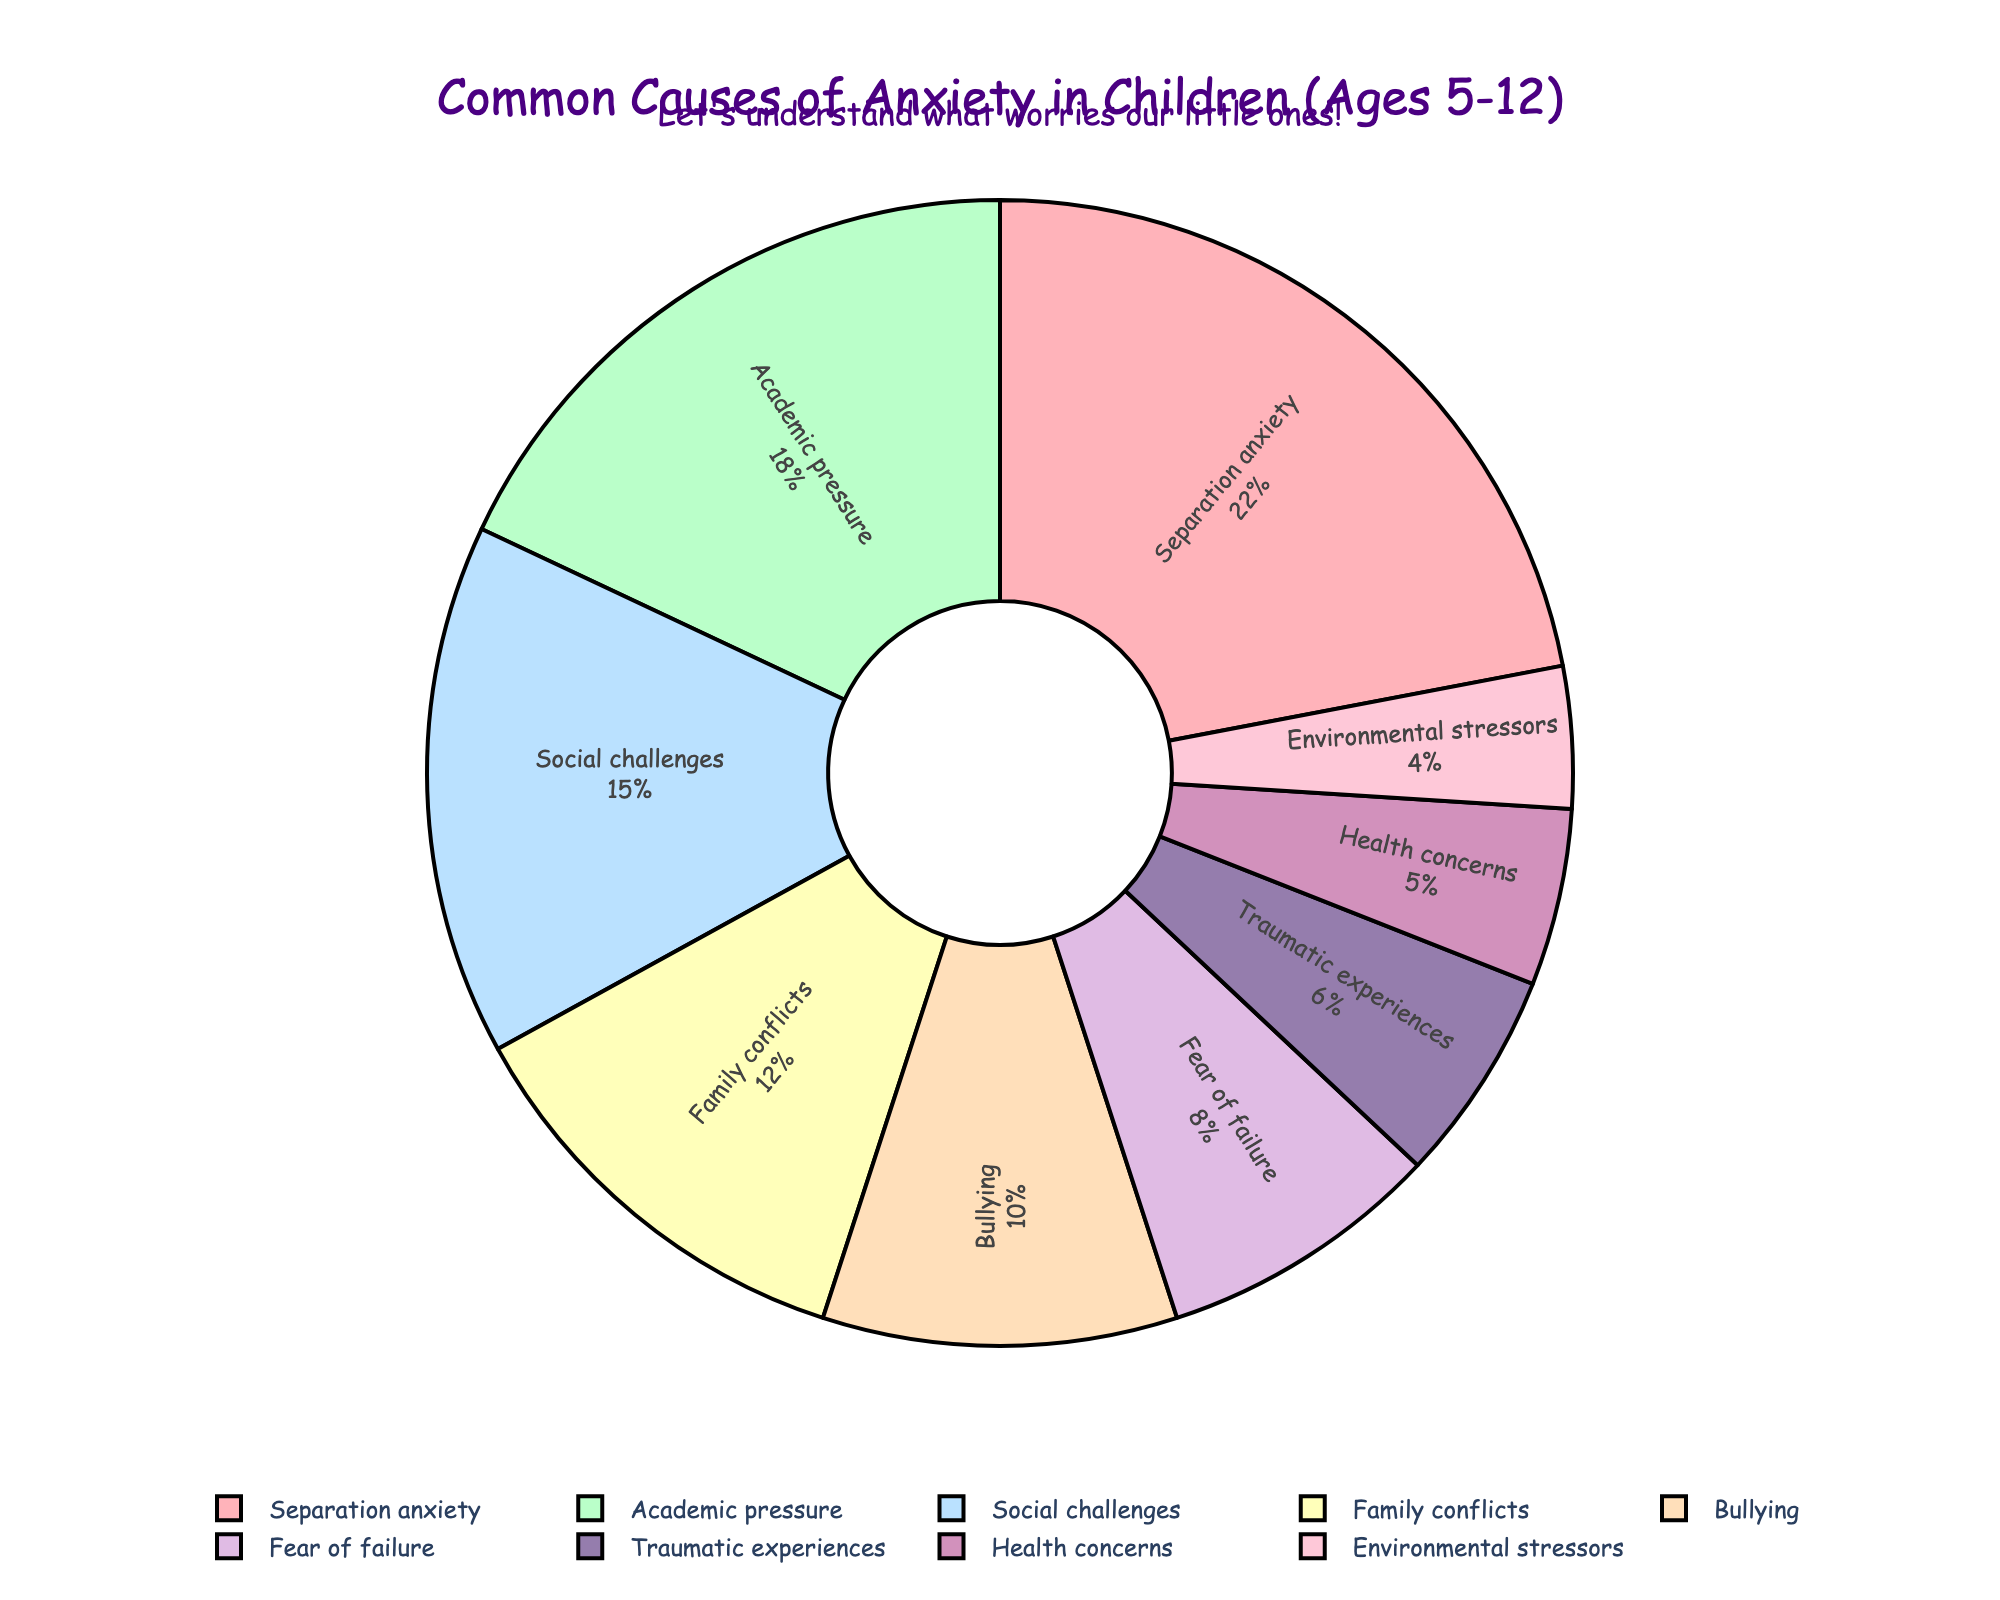Which cause has the highest percentage of anxiety in children aged 5-12? By observing the pie chart, the section representing "Separation anxiety" is the largest, which implies it has the highest percentage.
Answer: Separation anxiety Which causes make up more than 15% each? By looking at the pie chart, "Separation anxiety," "Academic pressure," and "Social challenges" have larger sections, each representing more than 15%.
Answer: Separation anxiety, Academic pressure, Social challenges How does the percentage of anxiety caused by "Family conflicts" compare to "Bullying"? Observing the pie chart, the section representing "Family conflicts" is larger than that of "Bullying."
Answer: Family conflicts is larger Which causes of anxiety are represented by the smallest sections in the pie chart? The smaller sections on the pie chart represent "Health concerns" and "Environmental stressors."
Answer: Health concerns, Environmental stressors What is the combined percentage of anxiety caused by "Traumatic experiences" and "Health concerns"? The pie chart shows "Traumatic experiences" at 6% and "Health concerns" at 5%. Adding these percentages together, the combined percentage is 6% + 5% = 11%.
Answer: 11% How much greater is the percentage for "Academic pressure" compared to "Fear of failure"? Comparing the pie chart percentages, "Academic pressure" is 18% and "Fear of failure" is 8%. The difference is 18% - 8% = 10%.
Answer: 10% Which causes of anxiety have a percentage within 2% of each other? By closely examining the pie chart, "Fear of failure" at 8% and "Traumatic experiences" at 6% are close, with only a 2% difference.
Answer: Fear of failure and Traumatic experiences What's the difference between the total percentage of "Separation anxiety" and "Environmental stressors"? The pie chart shows "Separation anxiety" at 22% and "Environmental stressors" at 4%. The difference is 22% - 4% = 18%.
Answer: 18% How does the percentage of "Social challenges" compare with "Family conflicts"? Observation of the pie chart indicates "Social challenges" is at 15%, while "Family conflicts" is at 12%, meaning "Social challenges" has a higher percentage.
Answer: Social challenges is higher 